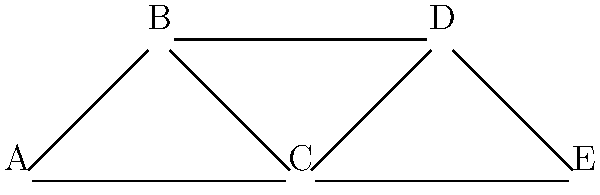Given the network graph of artist collaborations and shared genres, which artist would be considered most similar to artist C based on their connections? To determine the most similar artist to C, we need to analyze the connections in the graph:

1. Count the number of direct connections for each artist:
   A: 2 connections (B, C)
   B: 3 connections (A, C, D)
   C: 4 connections (A, B, D, E)
   D: 3 connections (B, C, E)
   E: 2 connections (C, D)

2. Identify artists directly connected to C:
   C is connected to A, B, D, and E

3. Compare the number of shared connections:
   A shares 2 connections with C (B, C)
   B shares 3 connections with C (A, C, D)
   D shares 3 connections with C (B, C, E)
   E shares 2 connections with C (C, D)

4. Evaluate the similarity based on shared connections:
   B and D both share the highest number of connections (3) with C

5. In case of a tie, consider the total number of connections:
   B has 3 total connections
   D has 3 total connections

Since B and D have the same number of shared connections with C and the same total number of connections, they are equally similar to C in this network.
Answer: B and D (equally similar) 